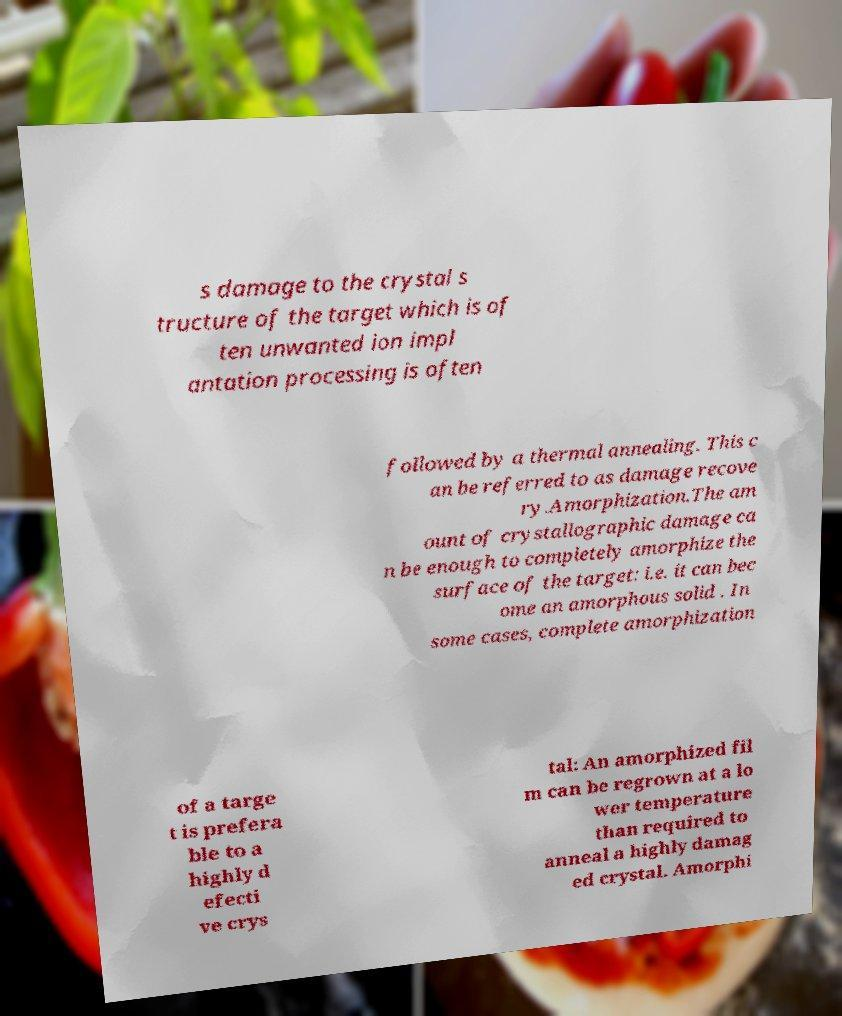For documentation purposes, I need the text within this image transcribed. Could you provide that? s damage to the crystal s tructure of the target which is of ten unwanted ion impl antation processing is often followed by a thermal annealing. This c an be referred to as damage recove ry.Amorphization.The am ount of crystallographic damage ca n be enough to completely amorphize the surface of the target: i.e. it can bec ome an amorphous solid . In some cases, complete amorphization of a targe t is prefera ble to a highly d efecti ve crys tal: An amorphized fil m can be regrown at a lo wer temperature than required to anneal a highly damag ed crystal. Amorphi 